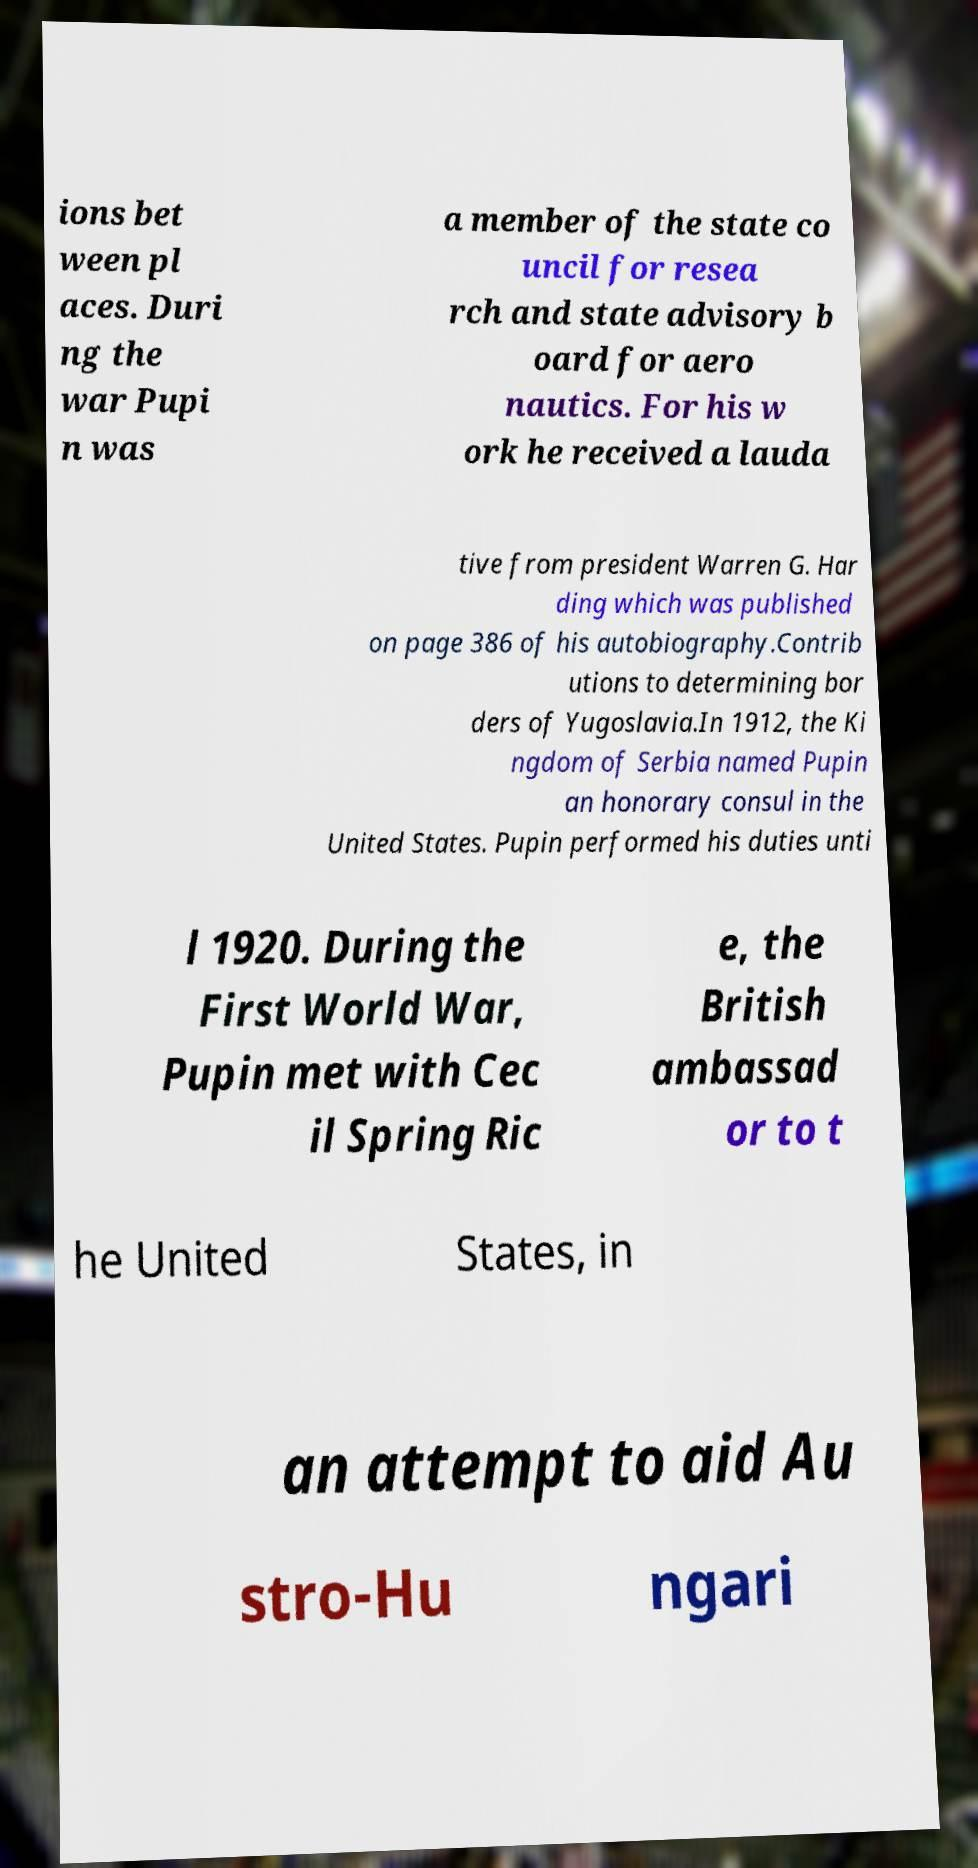What messages or text are displayed in this image? I need them in a readable, typed format. ions bet ween pl aces. Duri ng the war Pupi n was a member of the state co uncil for resea rch and state advisory b oard for aero nautics. For his w ork he received a lauda tive from president Warren G. Har ding which was published on page 386 of his autobiography.Contrib utions to determining bor ders of Yugoslavia.In 1912, the Ki ngdom of Serbia named Pupin an honorary consul in the United States. Pupin performed his duties unti l 1920. During the First World War, Pupin met with Cec il Spring Ric e, the British ambassad or to t he United States, in an attempt to aid Au stro-Hu ngari 